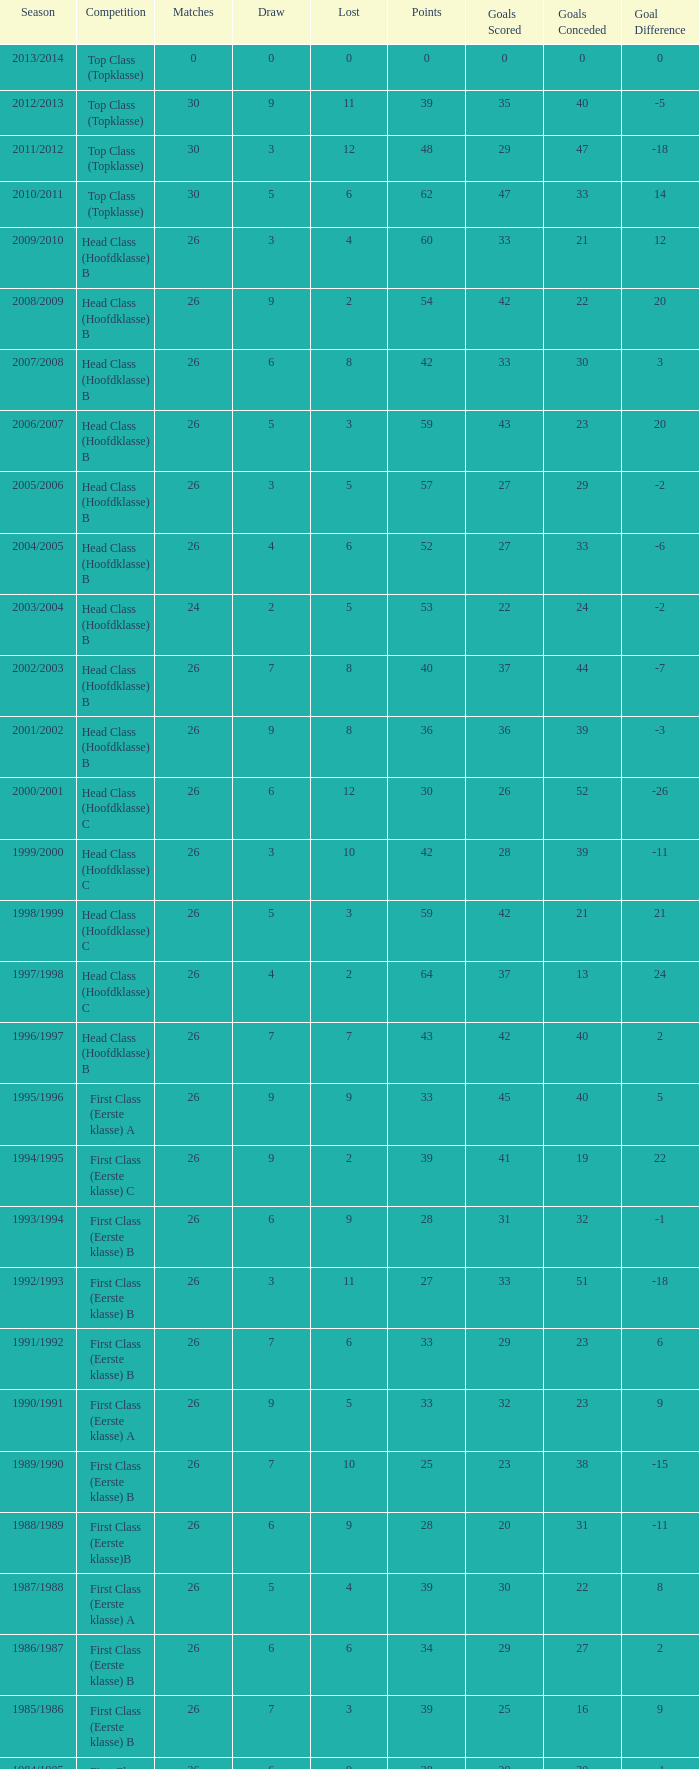What is the total number of matches with a loss less than 5 in the 2008/2009 season and has a draw larger than 9? 0.0. 